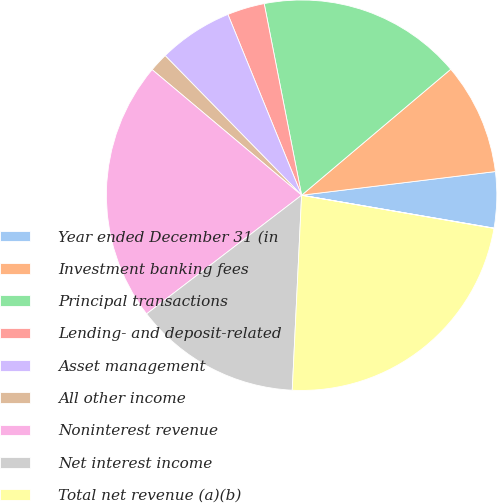Convert chart to OTSL. <chart><loc_0><loc_0><loc_500><loc_500><pie_chart><fcel>Year ended December 31 (in<fcel>Investment banking fees<fcel>Principal transactions<fcel>Lending- and deposit-related<fcel>Asset management<fcel>All other income<fcel>Noninterest revenue<fcel>Net interest income<fcel>Total net revenue (a)(b)<fcel>Provision for credit losses<nl><fcel>4.63%<fcel>9.23%<fcel>16.91%<fcel>3.09%<fcel>6.16%<fcel>1.56%<fcel>21.52%<fcel>13.84%<fcel>23.05%<fcel>0.02%<nl></chart> 